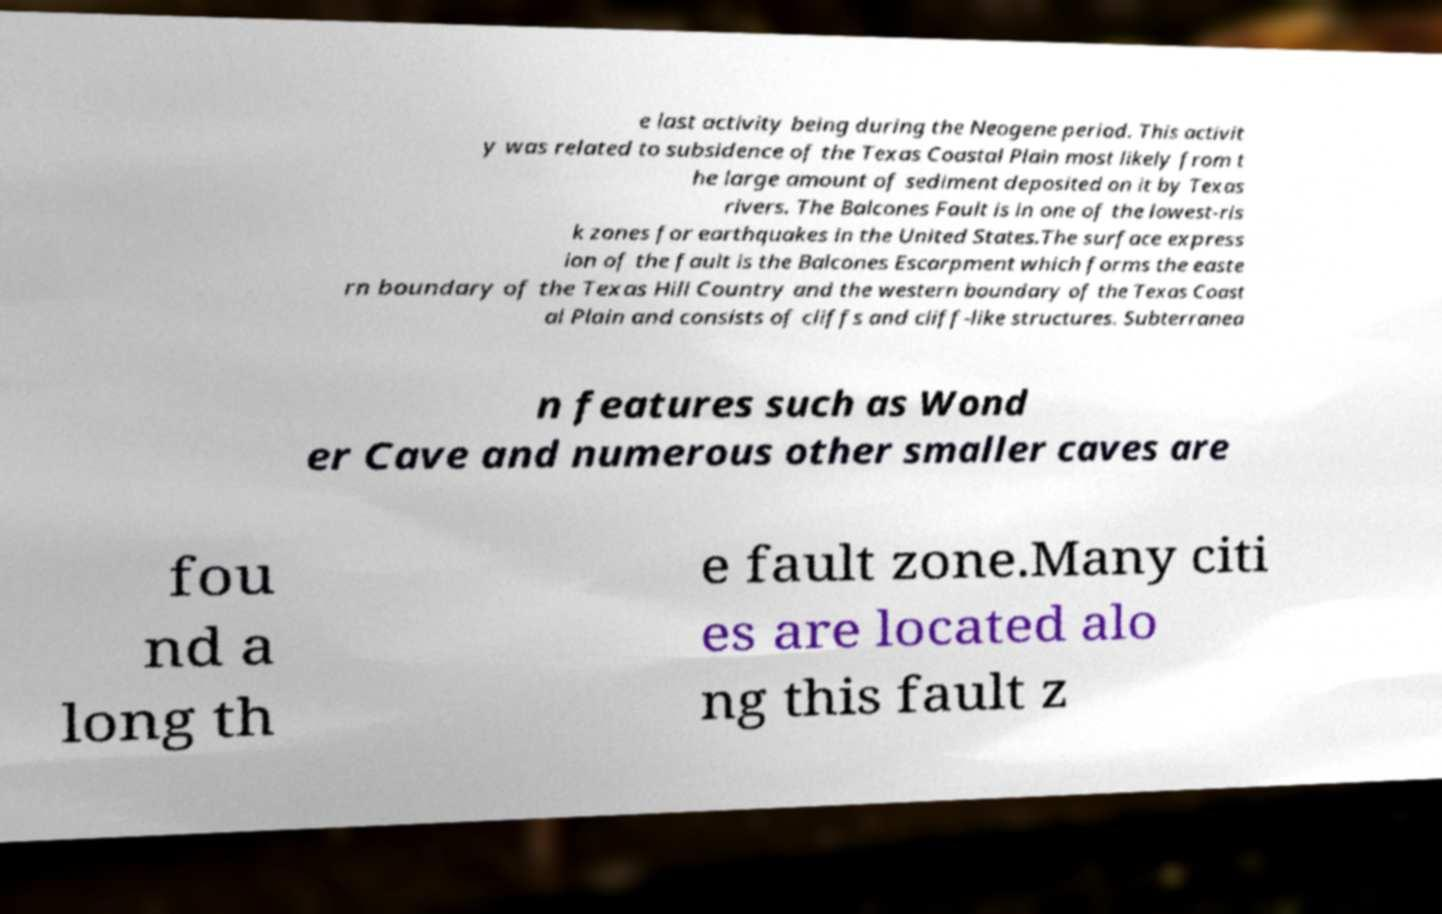Can you accurately transcribe the text from the provided image for me? e last activity being during the Neogene period. This activit y was related to subsidence of the Texas Coastal Plain most likely from t he large amount of sediment deposited on it by Texas rivers. The Balcones Fault is in one of the lowest-ris k zones for earthquakes in the United States.The surface express ion of the fault is the Balcones Escarpment which forms the easte rn boundary of the Texas Hill Country and the western boundary of the Texas Coast al Plain and consists of cliffs and cliff-like structures. Subterranea n features such as Wond er Cave and numerous other smaller caves are fou nd a long th e fault zone.Many citi es are located alo ng this fault z 